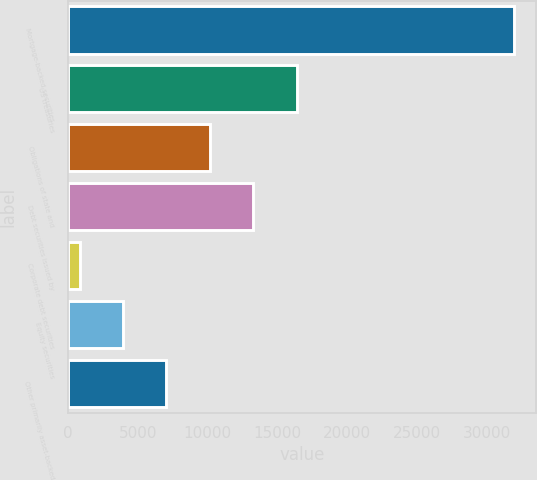<chart> <loc_0><loc_0><loc_500><loc_500><bar_chart><fcel>Mortgage-backed securities<fcel>US treasuries<fcel>Obligations of state and<fcel>Debt securities issued by<fcel>Corporate debt securities<fcel>Equity securities<fcel>Other primarily asset-backed<nl><fcel>31932<fcel>16382.5<fcel>10162.7<fcel>13272.6<fcel>833<fcel>3942.9<fcel>7052.8<nl></chart> 